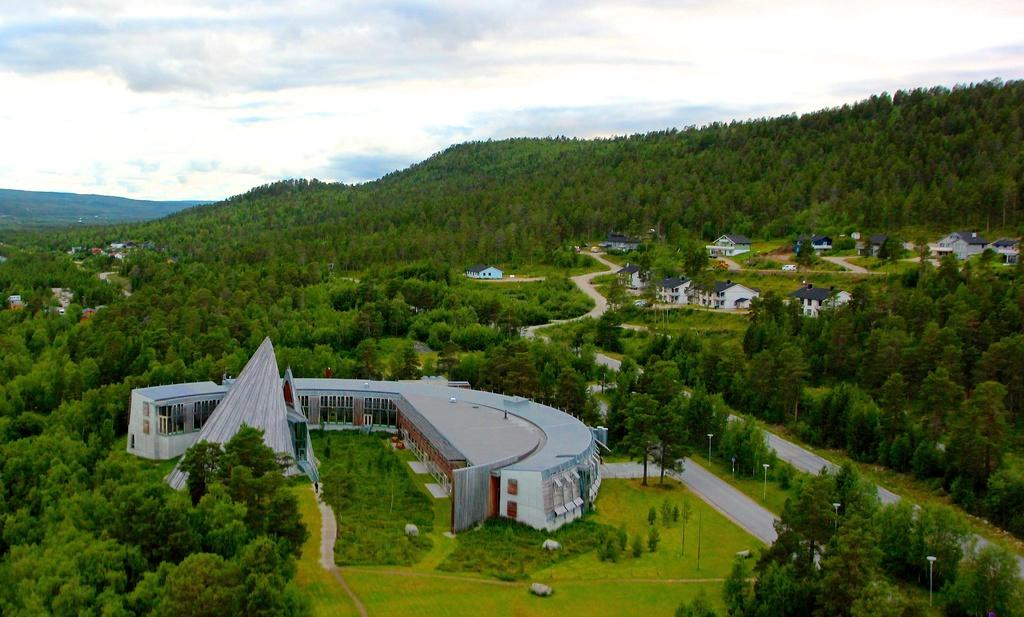What type of view is depicted in the image? The image is an aerial view. What structures can be seen in the image? There are houses in the image. Can you describe any specific architectural feature in the image? Yes, there is an architectural feature in the image. What type of natural vegetation is present in the image? There are trees in the image. What type of natural landform is visible in the image? There are mountains in the image. What is visible in the background of the image? The sky is visible in the image. What type of cub can be seen participating in the aftermath of a show in the image? There is no cub, aftermath of a show, or any related activity present in the image. 